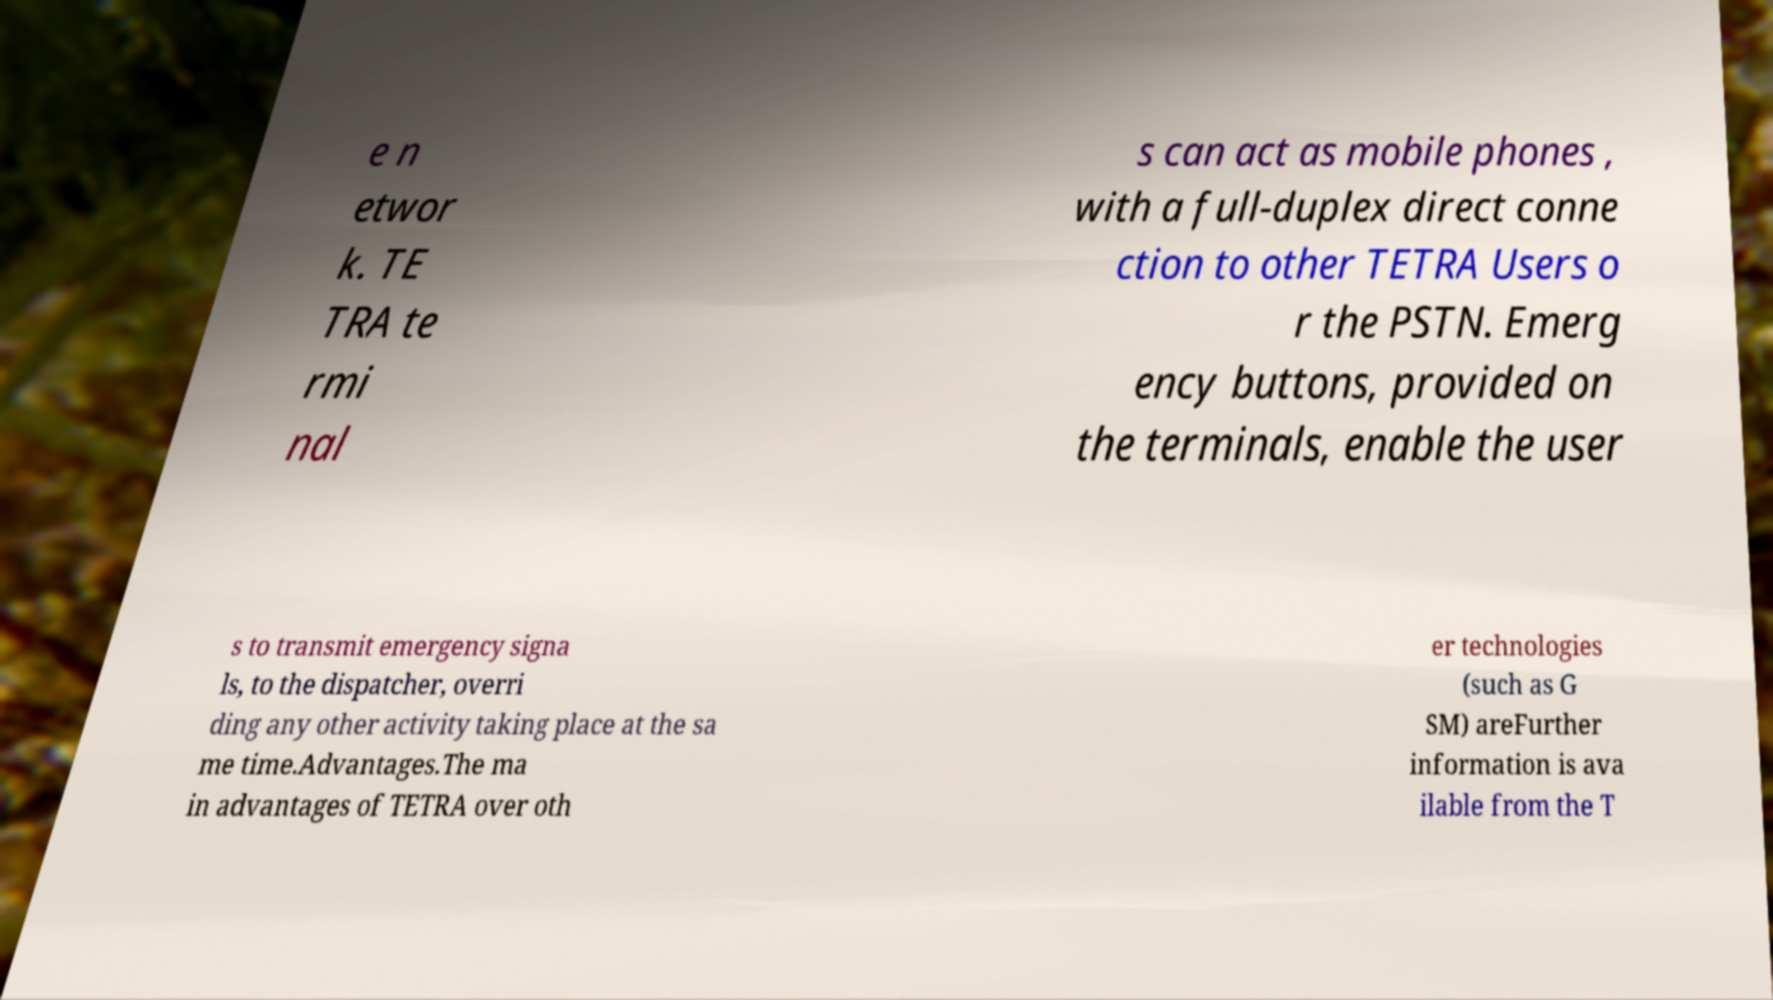Can you read and provide the text displayed in the image?This photo seems to have some interesting text. Can you extract and type it out for me? e n etwor k. TE TRA te rmi nal s can act as mobile phones , with a full-duplex direct conne ction to other TETRA Users o r the PSTN. Emerg ency buttons, provided on the terminals, enable the user s to transmit emergency signa ls, to the dispatcher, overri ding any other activity taking place at the sa me time.Advantages.The ma in advantages of TETRA over oth er technologies (such as G SM) areFurther information is ava ilable from the T 